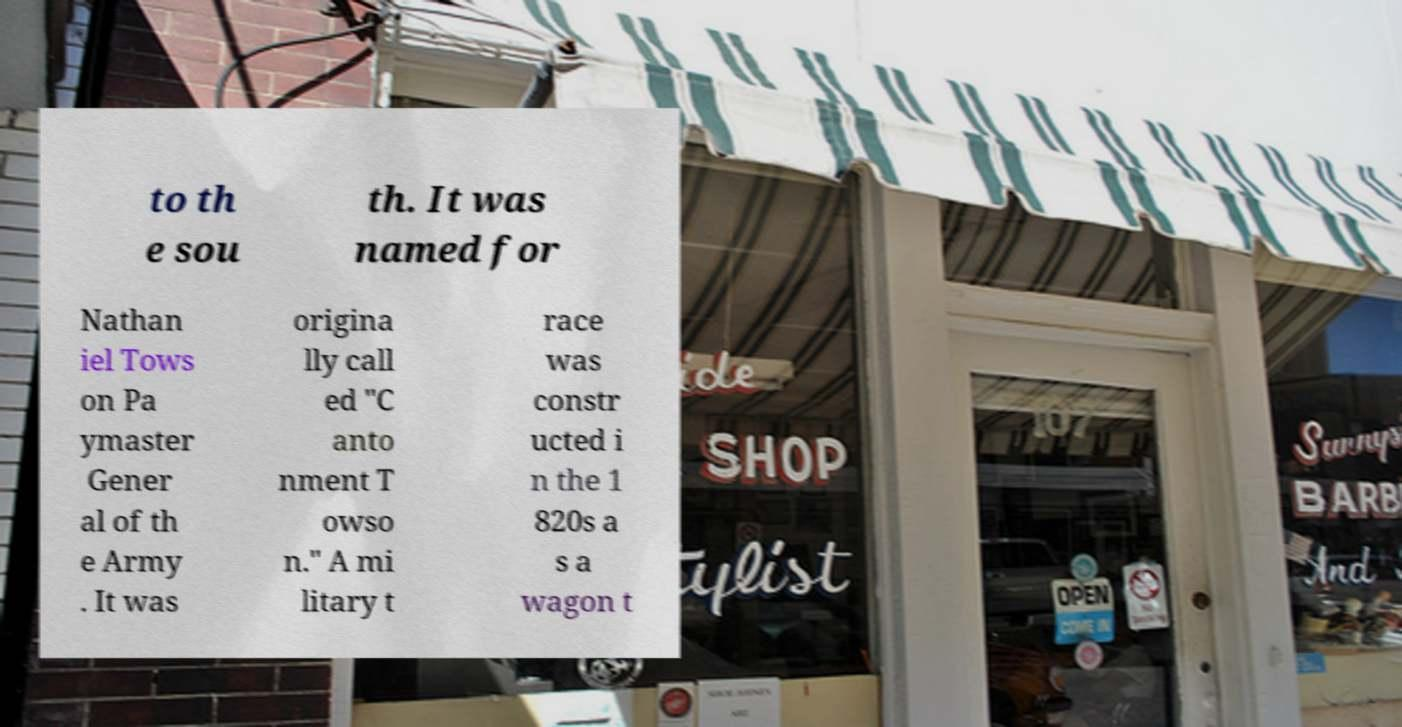Could you extract and type out the text from this image? to th e sou th. It was named for Nathan iel Tows on Pa ymaster Gener al of th e Army . It was origina lly call ed "C anto nment T owso n." A mi litary t race was constr ucted i n the 1 820s a s a wagon t 